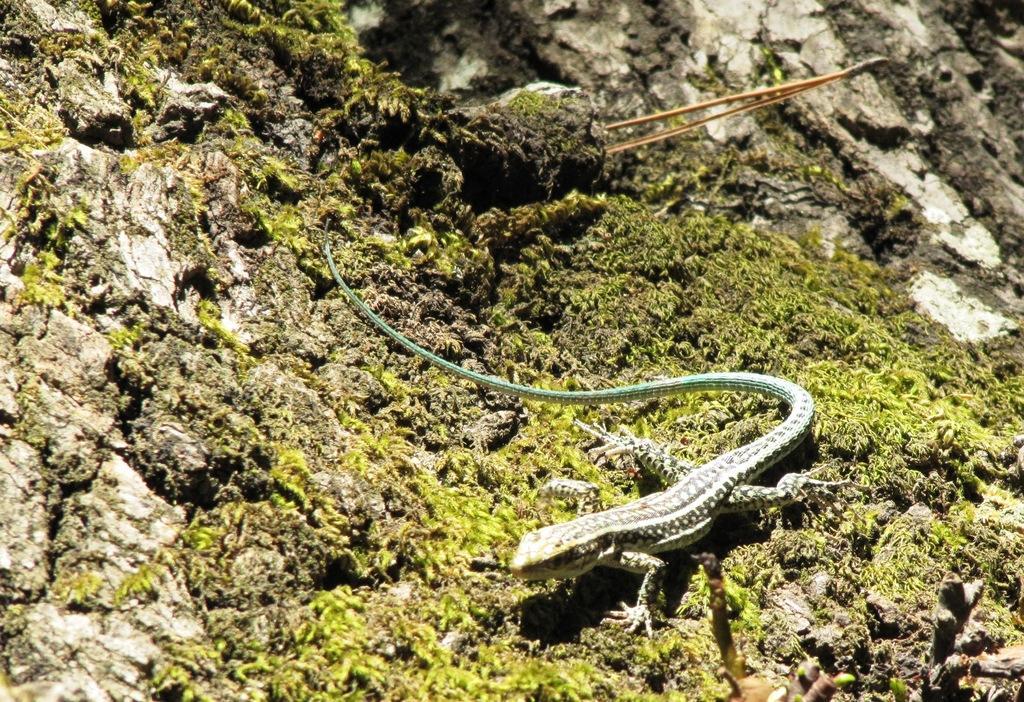Please provide a concise description of this image. This picture consists of lizard on stone , on the stone I can see small stick. 